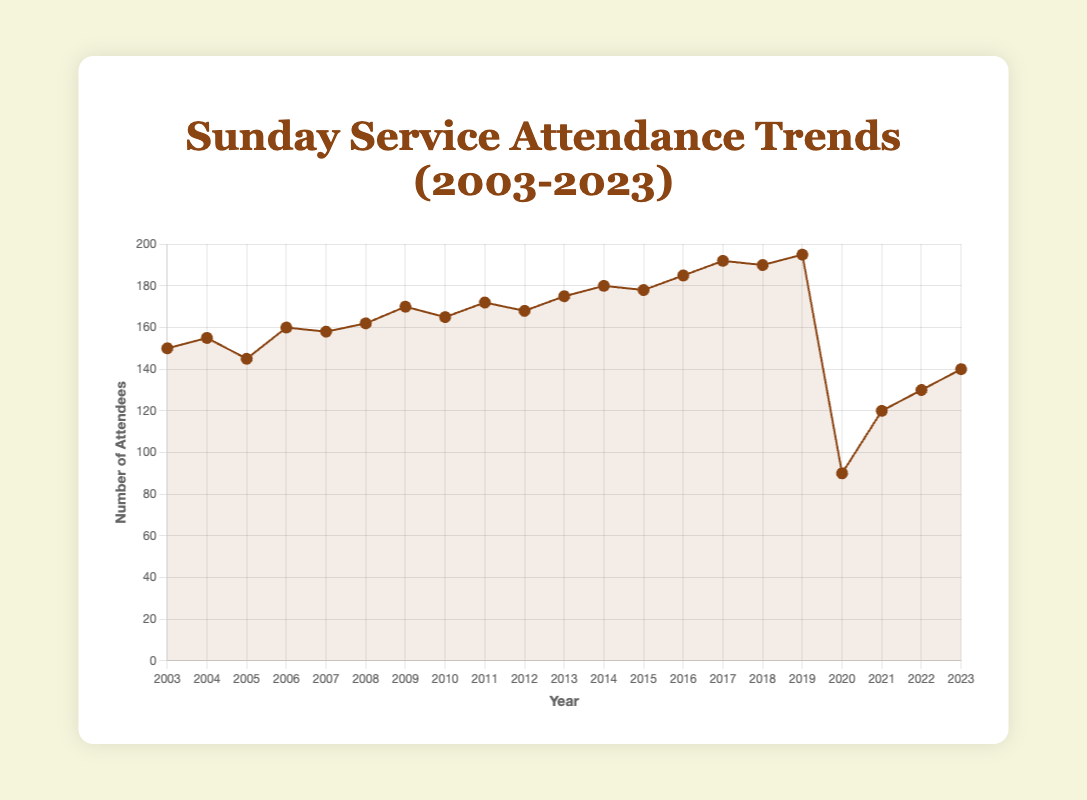What was the highest level of attendance recorded? To find the highest attendance, we need to look at the peak points on the line chart. The highest value recorded on the chart is in the year 2019 with an attendance of 195.
Answer: 195 How did the attendance change from 2019 to 2020? To assess the change, compare the attendance in 2019 and 2020. The attendance dropped from 195 in 2019 to 90 in 2020. The difference is 195 - 90 = 105.
Answer: Dropped by 105 What is the overall trend in attendance from 2003 to 2023? To determine the overall trend, observe the general direction of the line from the beginning to the end of the period. Attendance rose gradually from 150 in 2003 to 195 in 2019, then sharply dropped in 2020, eventually recovering to 140 by 2023.
Answer: Generally increasing until 2019, then dropped, recovering by 2023 Which year had the lowest attendance recorded, excluding the year 2020? Ignore the value for 2020 and look for the smallest attendance value among the other years. The lowest attendance excluding 2020 is 130 in 2005.
Answer: 2005 How much did the attendance increase from 2003 to 2019? Calculate the difference between the attendance in 2003 and 2019. Attendance was 150 in 2003 and 195 in 2019. The increase is 195 - 150 = 45.
Answer: Increased by 45 Which years showed a decrease in attendance compared to the previous year? Identify years where the attendance is less than the previous year's attendance. These years are 2005, 2007, 2010, 2012, 2015, 2018, 2020, and 2021.
Answer: 2005, 2007, 2010, 2012, 2015, 2018, 2020, 2021 Estimate the average annual attendance over the 20-year period. Sum the attendance values from 2003 to 2023 and divide by the number of years (21). The total attendance sum is 3137. The average is 3137 / 21 ≈ 149.38.
Answer: Approximately 149.38 How does the attendance in 2023 compare with the attendance at its lowest point in 2020? Compare the attendance values of 2023 and 2020. In 2020, attendance was 90 and in 2023, it was 140. Attendance in 2023 is higher by 140 - 90 = 50.
Answer: Higher by 50 What depicts a sharp drop in the attendance chart? A sharp drop is visible between 2019 and 2020 when the attendance fell from 195 to 90.
Answer: Drop between 2019 and 2020 How many years saw an attendance over 180? Count the years where attendance exceeded 180. These years are 2014, 2016, 2017, 2018, and 2019 (5 years).
Answer: 5 years 